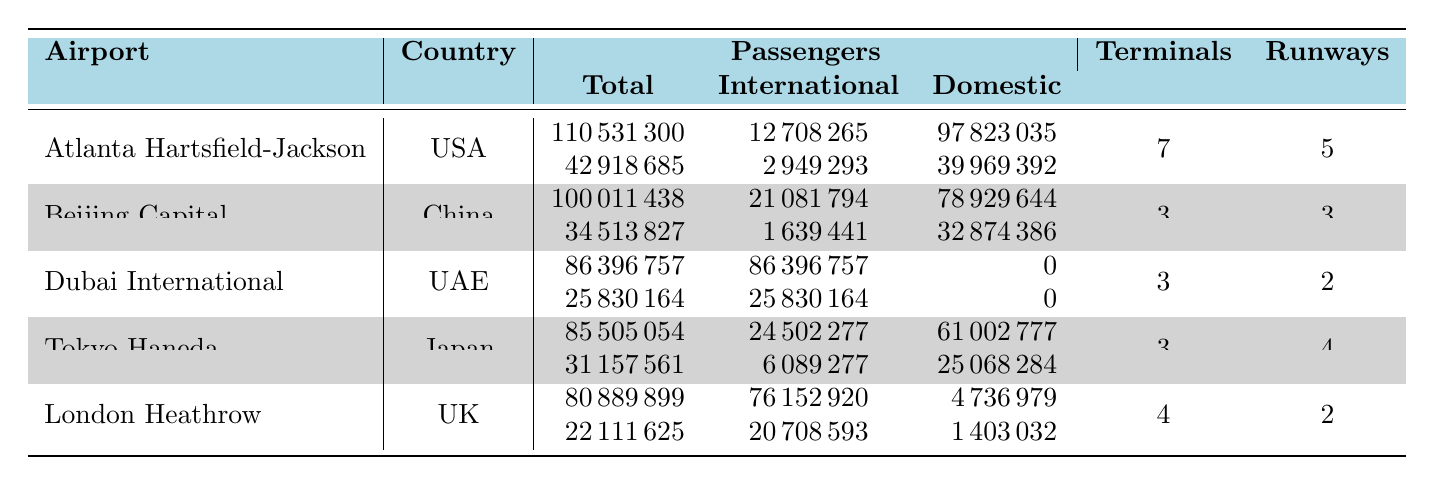What airport had the highest total number of passengers in 2019? By examining the "Passengers" column for the year 2019, we see that Atlanta Hartsfield-Jackson has the highest total, with 110,531,300 passengers.
Answer: Atlanta Hartsfield-Jackson How many international passengers did Dubai International have in 2020? Looking at the "International" column for Dubai International in 2020, it shows a total of 25,830,164 international passengers.
Answer: 25,830,164 What is the average number of runways across all airports listed? By summing the "Runway Count" for each airport: 5 + 3 + 2 + 4 + 2 = 16. There are 5 airports, so the average is 16/5 = 3.2.
Answer: 3.2 Did Tokyo Haneda have more international or domestic passengers in 2019? In 2019, Tokyo Haneda had 24,502,277 international passengers and 61,002,777 domestic passengers. Since 61,002,777 > 24,502,277, it means domestic passengers were greater.
Answer: Yes, domestic passengers were more What was the total passenger traffic for London Heathrow in 2020? The "Passengers" column for London Heathrow in 2020 shows a total of 22,111,625 passengers.
Answer: 22,111,625 How much did the total passenger traffic decrease for Atlanta Hartsfield-Jackson from 2019 to 2020? For Atlanta Hartsfield-Jackson, the total passengers in 2019 were 110,531,300 and in 2020 were 42,918,685. The decrease is 110,531,300 - 42,918,685 = 67,612,615.
Answer: 67,612,615 Is it true that all passengers at Dubai International in 2019 were international? The data shows that Dubai International had a total of 86,396,757 passengers in 2019, with 86,396,757 classified as international and 0 domestic. This confirms that all were indeed international.
Answer: Yes, that's true Which airport had the most significant difference in domestic passengers between 2019 and 2020? Looking at the domestic passenger counts: Atlanta Hartsfield-Jackson had 97,823,035 in 2019 and 39,969,392 in 2020, a difference of 57,853,643. For London Heathrow, the difference is 4,736,979 (2019) vs 1,403,032 (2020), a difference of 3,333,947. Hence, the most significant difference is for Atlanta Hartsfield-Jackson.
Answer: Atlanta Hartsfield-Jackson 